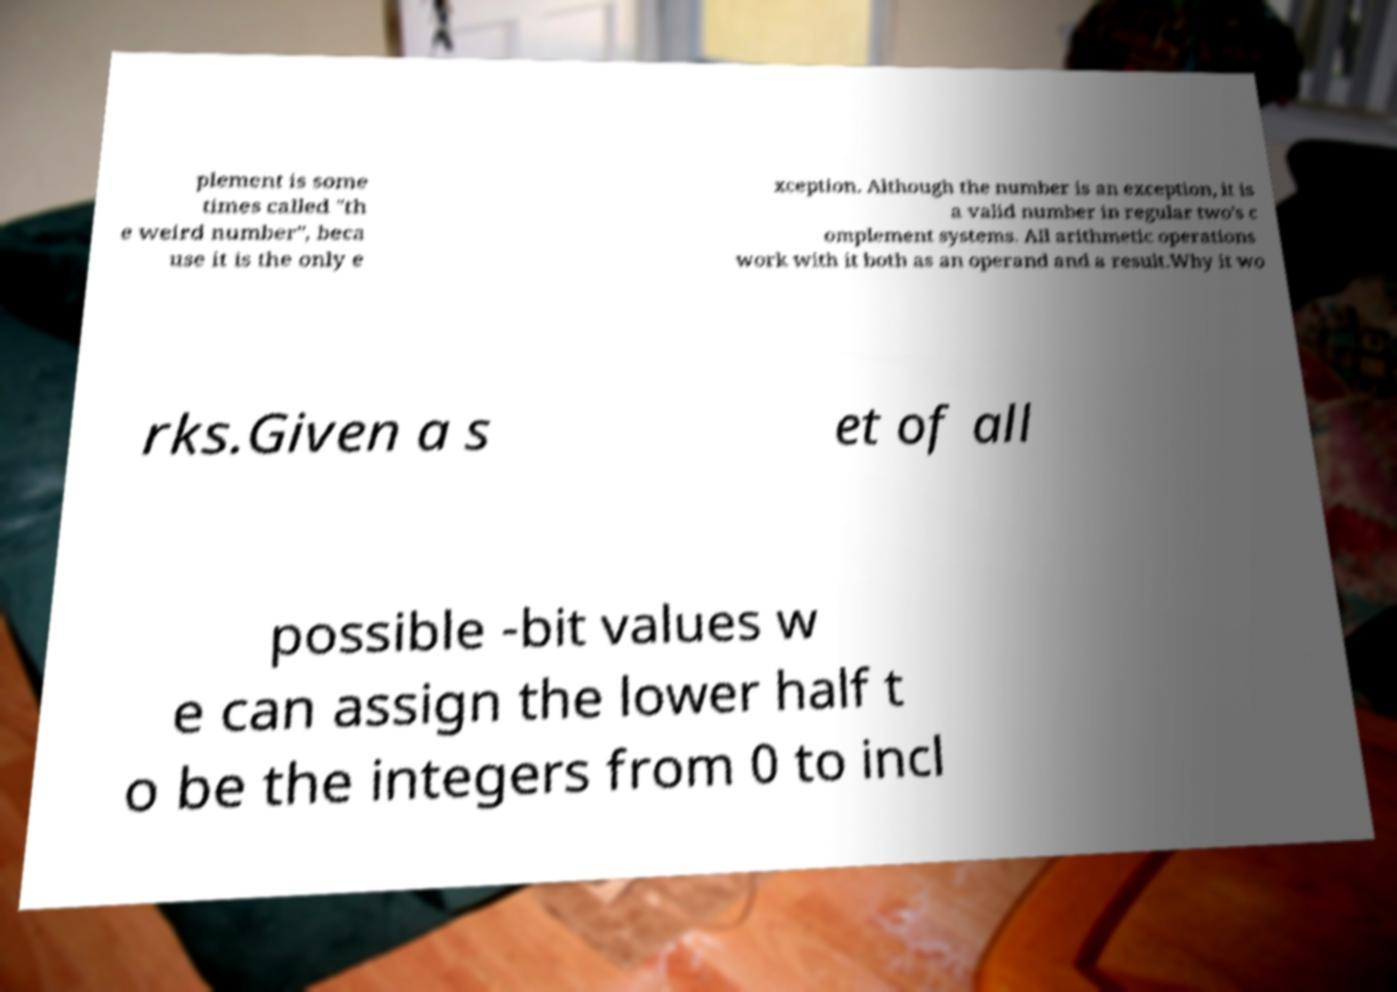Could you assist in decoding the text presented in this image and type it out clearly? plement is some times called "th e weird number", beca use it is the only e xception. Although the number is an exception, it is a valid number in regular two's c omplement systems. All arithmetic operations work with it both as an operand and a result.Why it wo rks.Given a s et of all possible -bit values w e can assign the lower half t o be the integers from 0 to incl 